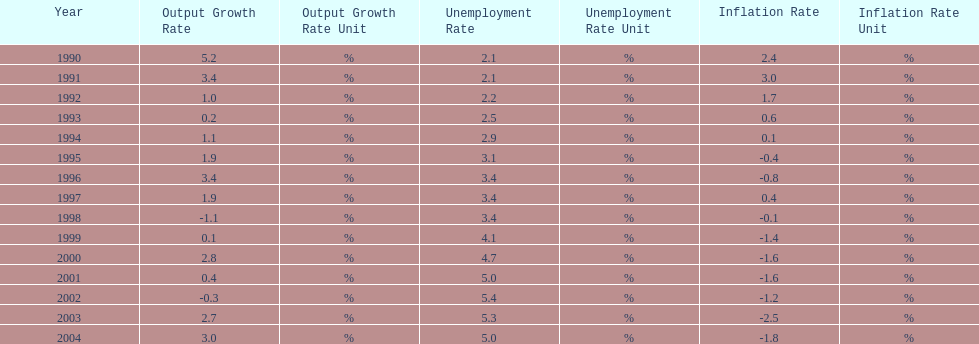What year had the highest unemployment rate? 2002. 